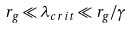<formula> <loc_0><loc_0><loc_500><loc_500>r _ { g } \ll \lambda _ { c r i t } \ll r _ { g } / \gamma</formula> 